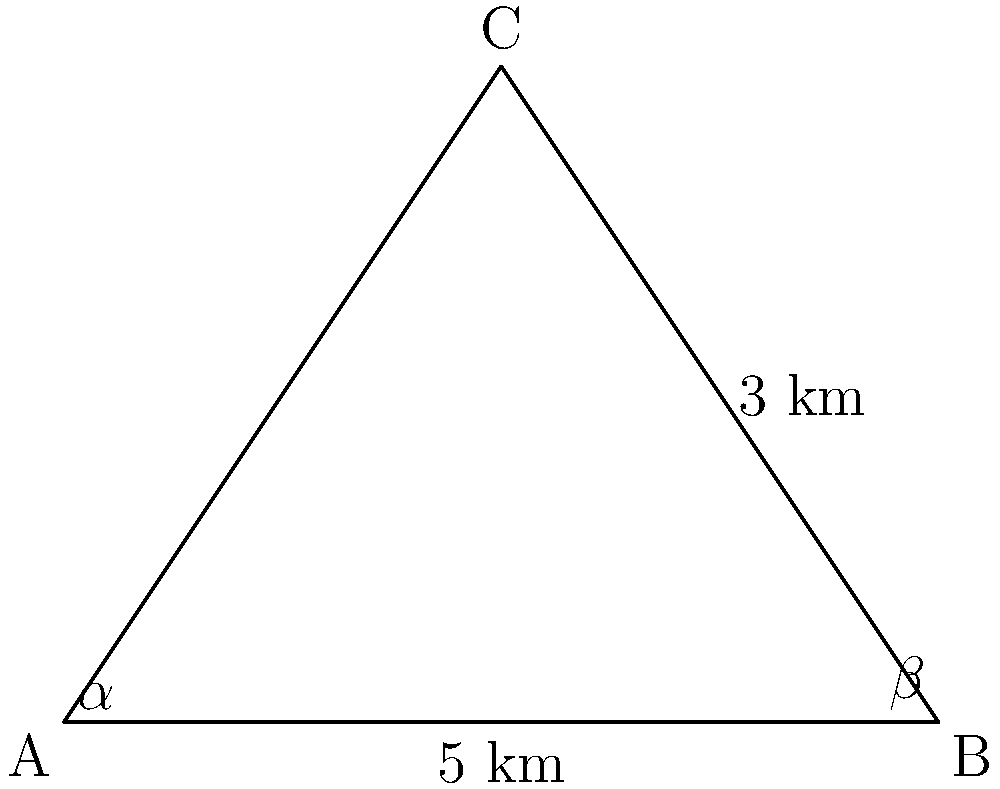Two rival comedy troupes, "Smekh" and "Yumor," are performing in different venues in Moscow. The distance between their venues forms a triangle with a nearby landmark. If the distance from "Smekh" to the landmark is 3 km, the distance between "Smekh" and "Yumor" is 5 km, and the angle at "Smekh" (α) is 60°, what is the distance between "Yumor" and the landmark? Round your answer to the nearest tenth of a kilometer. Let's solve this step-by-step using the law of sines:

1) Let's define our triangle:
   A: "Smekh"
   B: "Yumor"
   C: Landmark

2) We know:
   AB = 5 km
   AC = 3 km
   ∠A = α = 60°

3) We need to find BC. Let's call the angle at B as β.

4) The law of sines states:
   $$\frac{a}{\sin A} = \frac{b}{\sin B} = \frac{c}{\sin C}$$

5) We can use this to set up an equation:
   $$\frac{5}{\sin 60°} = \frac{3}{\sin \beta}$$

6) Solve for sin β:
   $$\sin \beta = \frac{3 \sin 60°}{5} = \frac{3 \cdot \frac{\sqrt{3}}{2}}{5} = \frac{3\sqrt{3}}{10}$$

7) Now we can find β:
   $$\beta = \arcsin(\frac{3\sqrt{3}}{10}) \approx 30.96°$$

8) We can find ∠C by subtracting ∠A and ∠B from 180°:
   $$\angle C = 180° - 60° - 30.96° = 89.04°$$

9) Now we can use the law of sines again to find BC:
   $$\frac{BC}{\sin 60°} = \frac{5}{\sin 89.04°}$$

10) Solve for BC:
    $$BC = \frac{5 \sin 60°}{\sin 89.04°} \approx 4.3 km$$

11) Rounding to the nearest tenth: 4.3 km
Answer: 4.3 km 